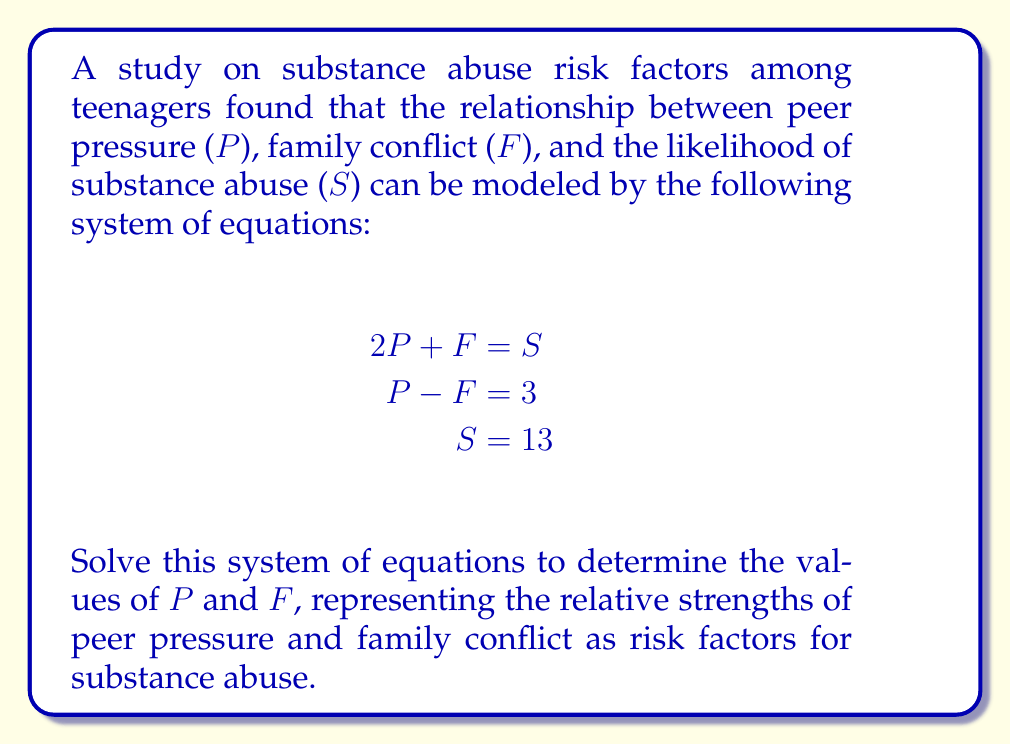Provide a solution to this math problem. Let's solve this system of equations step by step:

1) We have three equations:
   $$\begin{align}
   2P + F &= S \tag{1}\\
   P - F &= 3 \tag{2}\\
   S &= 13 \tag{3}
   \end{align}$$

2) From equation (3), we know that $S = 13$. Let's substitute this into equation (1):
   $$2P + F = 13 \tag{4}$$

3) Now we have two equations with two unknowns (P and F):
   $$\begin{align}
   2P + F &= 13 \tag{4}\\
   P - F &= 3 \tag{2}
   \end{align}$$

4) Let's add these equations to eliminate F:
   $$(2P + F) + (P - F) = 13 + 3$$
   $$3P = 16$$

5) Solving for P:
   $$P = \frac{16}{3} \approx 5.33$$

6) Now that we know P, we can substitute it back into equation (2) to find F:
   $$\frac{16}{3} - F = 3$$
   $$-F = 3 - \frac{16}{3} = \frac{9-16}{3} = -\frac{7}{3}$$
   $$F = \frac{7}{3} \approx 2.33$$

7) We can verify our solution by substituting these values into equation (1):
   $$2(\frac{16}{3}) + \frac{7}{3} = \frac{32}{3} + \frac{7}{3} = \frac{39}{3} = 13$$

Therefore, the relative strength of peer pressure (P) is $\frac{16}{3}$ and the relative strength of family conflict (F) is $\frac{7}{3}$.
Answer: $P = \frac{16}{3}, F = \frac{7}{3}$ 